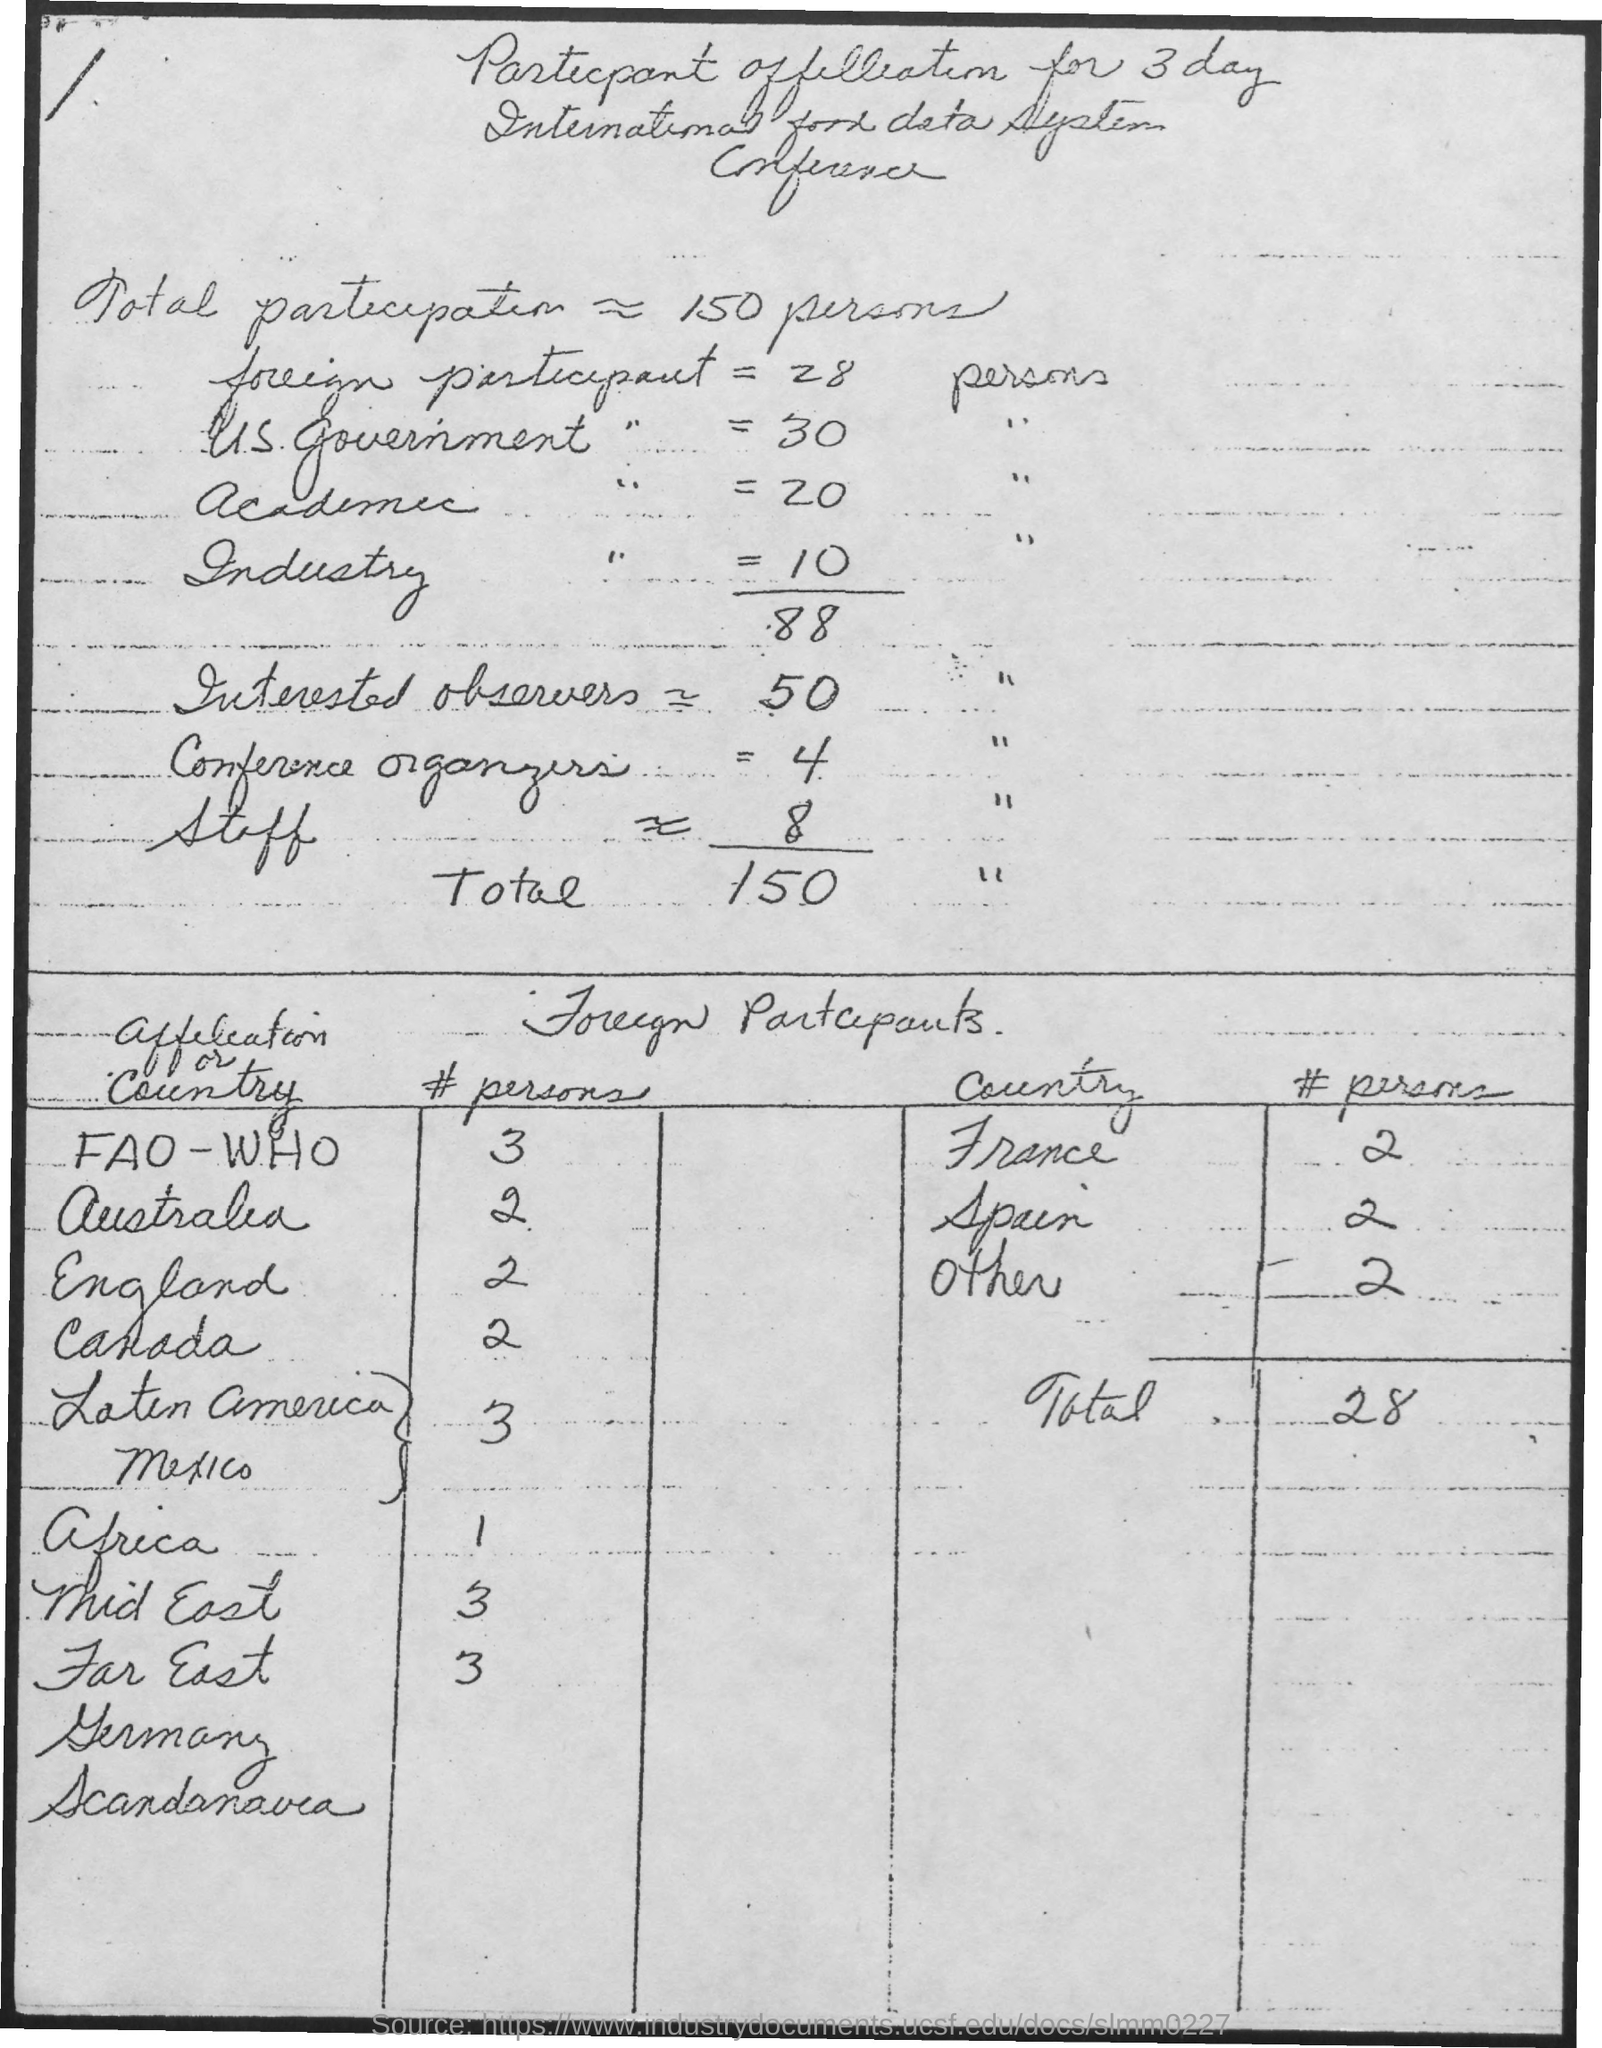Outline some significant characteristics in this image. What is the number of people from Spain? It is 2.. There were 20 academic participants in the event. The number of foreign participants is 28. The number of industry participants is 10. There are 2 people from France. 